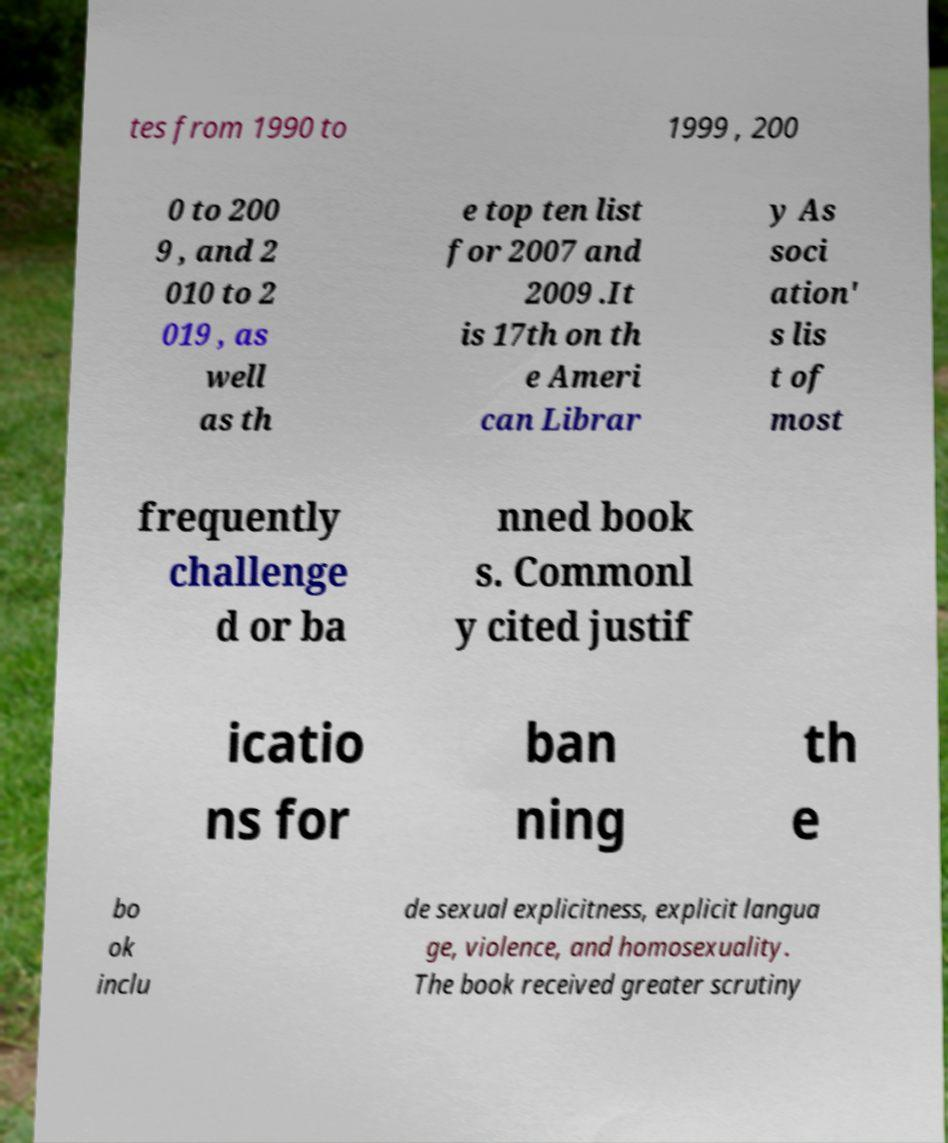For documentation purposes, I need the text within this image transcribed. Could you provide that? tes from 1990 to 1999 , 200 0 to 200 9 , and 2 010 to 2 019 , as well as th e top ten list for 2007 and 2009 .It is 17th on th e Ameri can Librar y As soci ation' s lis t of most frequently challenge d or ba nned book s. Commonl y cited justif icatio ns for ban ning th e bo ok inclu de sexual explicitness, explicit langua ge, violence, and homosexuality. The book received greater scrutiny 